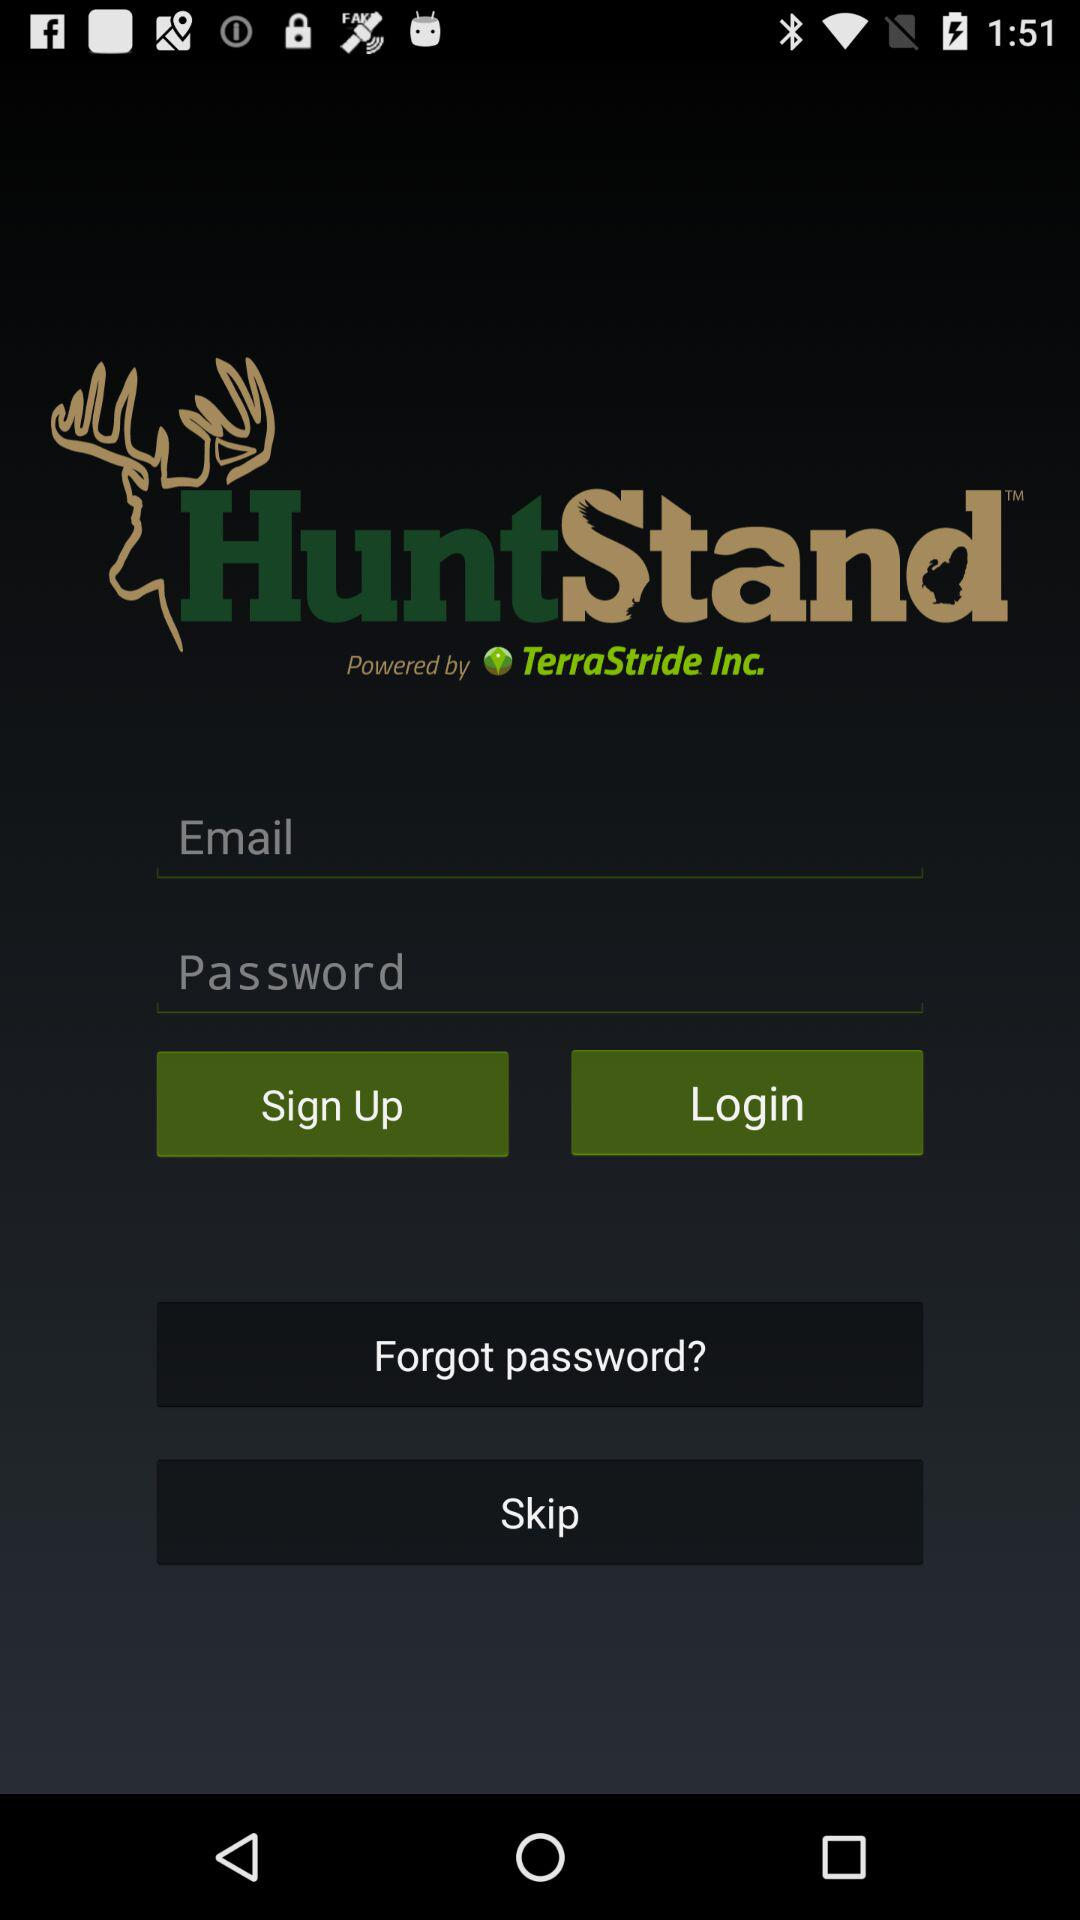What is the application name? The application name is "HuntStand". 